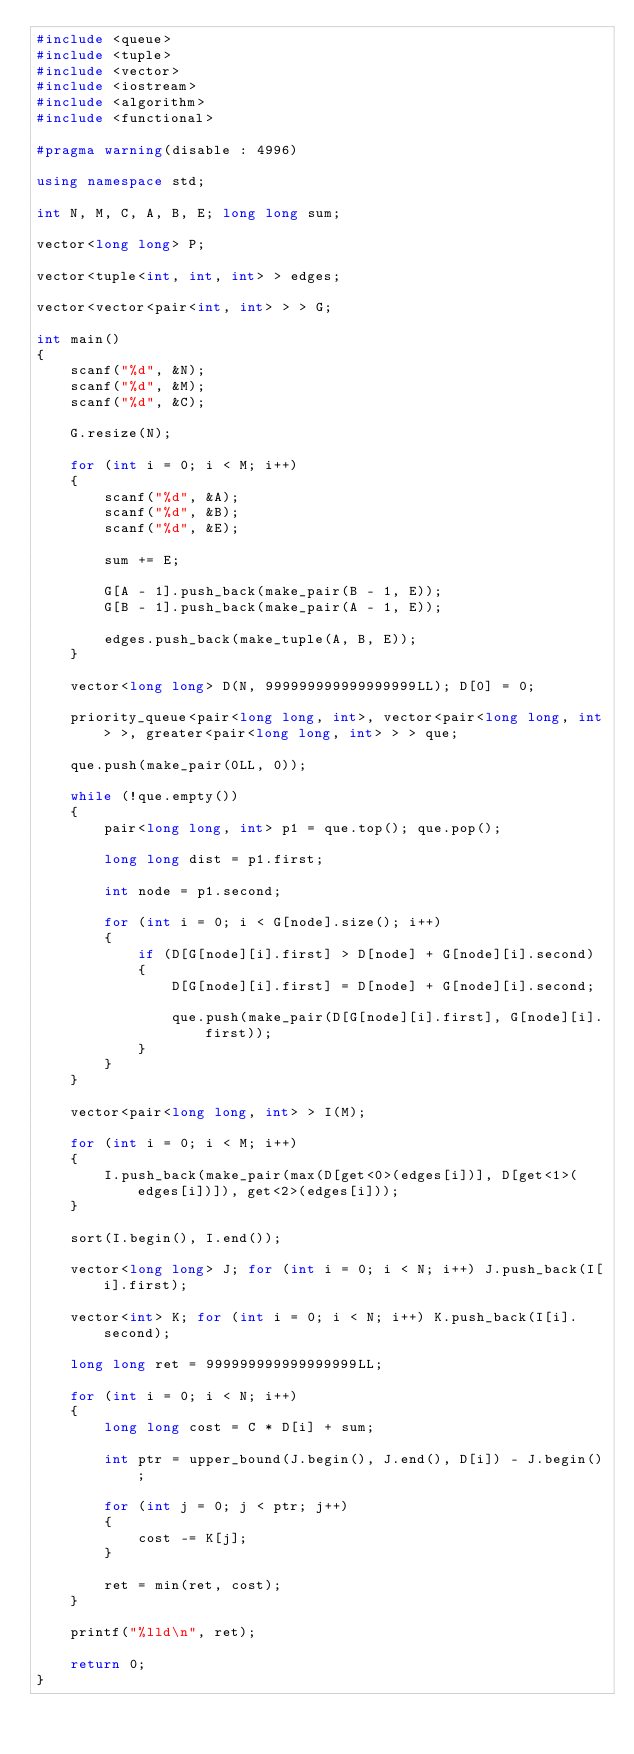<code> <loc_0><loc_0><loc_500><loc_500><_C++_>#include <queue>
#include <tuple>
#include <vector>
#include <iostream>
#include <algorithm>
#include <functional>

#pragma warning(disable : 4996)

using namespace std;

int N, M, C, A, B, E; long long sum;

vector<long long> P;

vector<tuple<int, int, int> > edges;

vector<vector<pair<int, int> > > G;

int main()
{
	scanf("%d", &N);
	scanf("%d", &M);
	scanf("%d", &C);

	G.resize(N);

	for (int i = 0; i < M; i++)
	{
		scanf("%d", &A);
		scanf("%d", &B);
		scanf("%d", &E);

		sum += E;

		G[A - 1].push_back(make_pair(B - 1, E));
		G[B - 1].push_back(make_pair(A - 1, E));

		edges.push_back(make_tuple(A, B, E));
	}

	vector<long long> D(N, 999999999999999999LL); D[0] = 0;

	priority_queue<pair<long long, int>, vector<pair<long long, int> >, greater<pair<long long, int> > > que;

	que.push(make_pair(0LL, 0));

	while (!que.empty())
	{
		pair<long long, int> p1 = que.top(); que.pop();

		long long dist = p1.first;

		int node = p1.second;

		for (int i = 0; i < G[node].size(); i++)
		{
			if (D[G[node][i].first] > D[node] + G[node][i].second)
			{
				D[G[node][i].first] = D[node] + G[node][i].second;

				que.push(make_pair(D[G[node][i].first], G[node][i].first));
			}
		}
	}

	vector<pair<long long, int> > I(M);

	for (int i = 0; i < M; i++)
	{
		I.push_back(make_pair(max(D[get<0>(edges[i])], D[get<1>(edges[i])]), get<2>(edges[i]));
	}

	sort(I.begin(), I.end());

	vector<long long> J; for (int i = 0; i < N; i++) J.push_back(I[i].first);

	vector<int> K; for (int i = 0; i < N; i++) K.push_back(I[i].second);

	long long ret = 999999999999999999LL;

	for (int i = 0; i < N; i++)
	{
		long long cost = C * D[i] + sum;

		int ptr = upper_bound(J.begin(), J.end(), D[i]) - J.begin();

		for (int j = 0; j < ptr; j++)
		{
			cost -= K[j];
		}

		ret = min(ret, cost);
	}

	printf("%lld\n", ret);

	return 0;
}</code> 